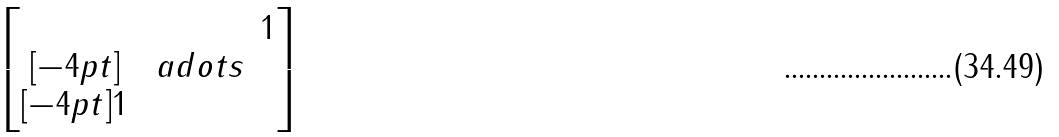<formula> <loc_0><loc_0><loc_500><loc_500>\begin{bmatrix} & & 1 \\ [ - 4 p t ] & \ a d o t s & \\ [ - 4 p t ] 1 & & \end{bmatrix}</formula> 